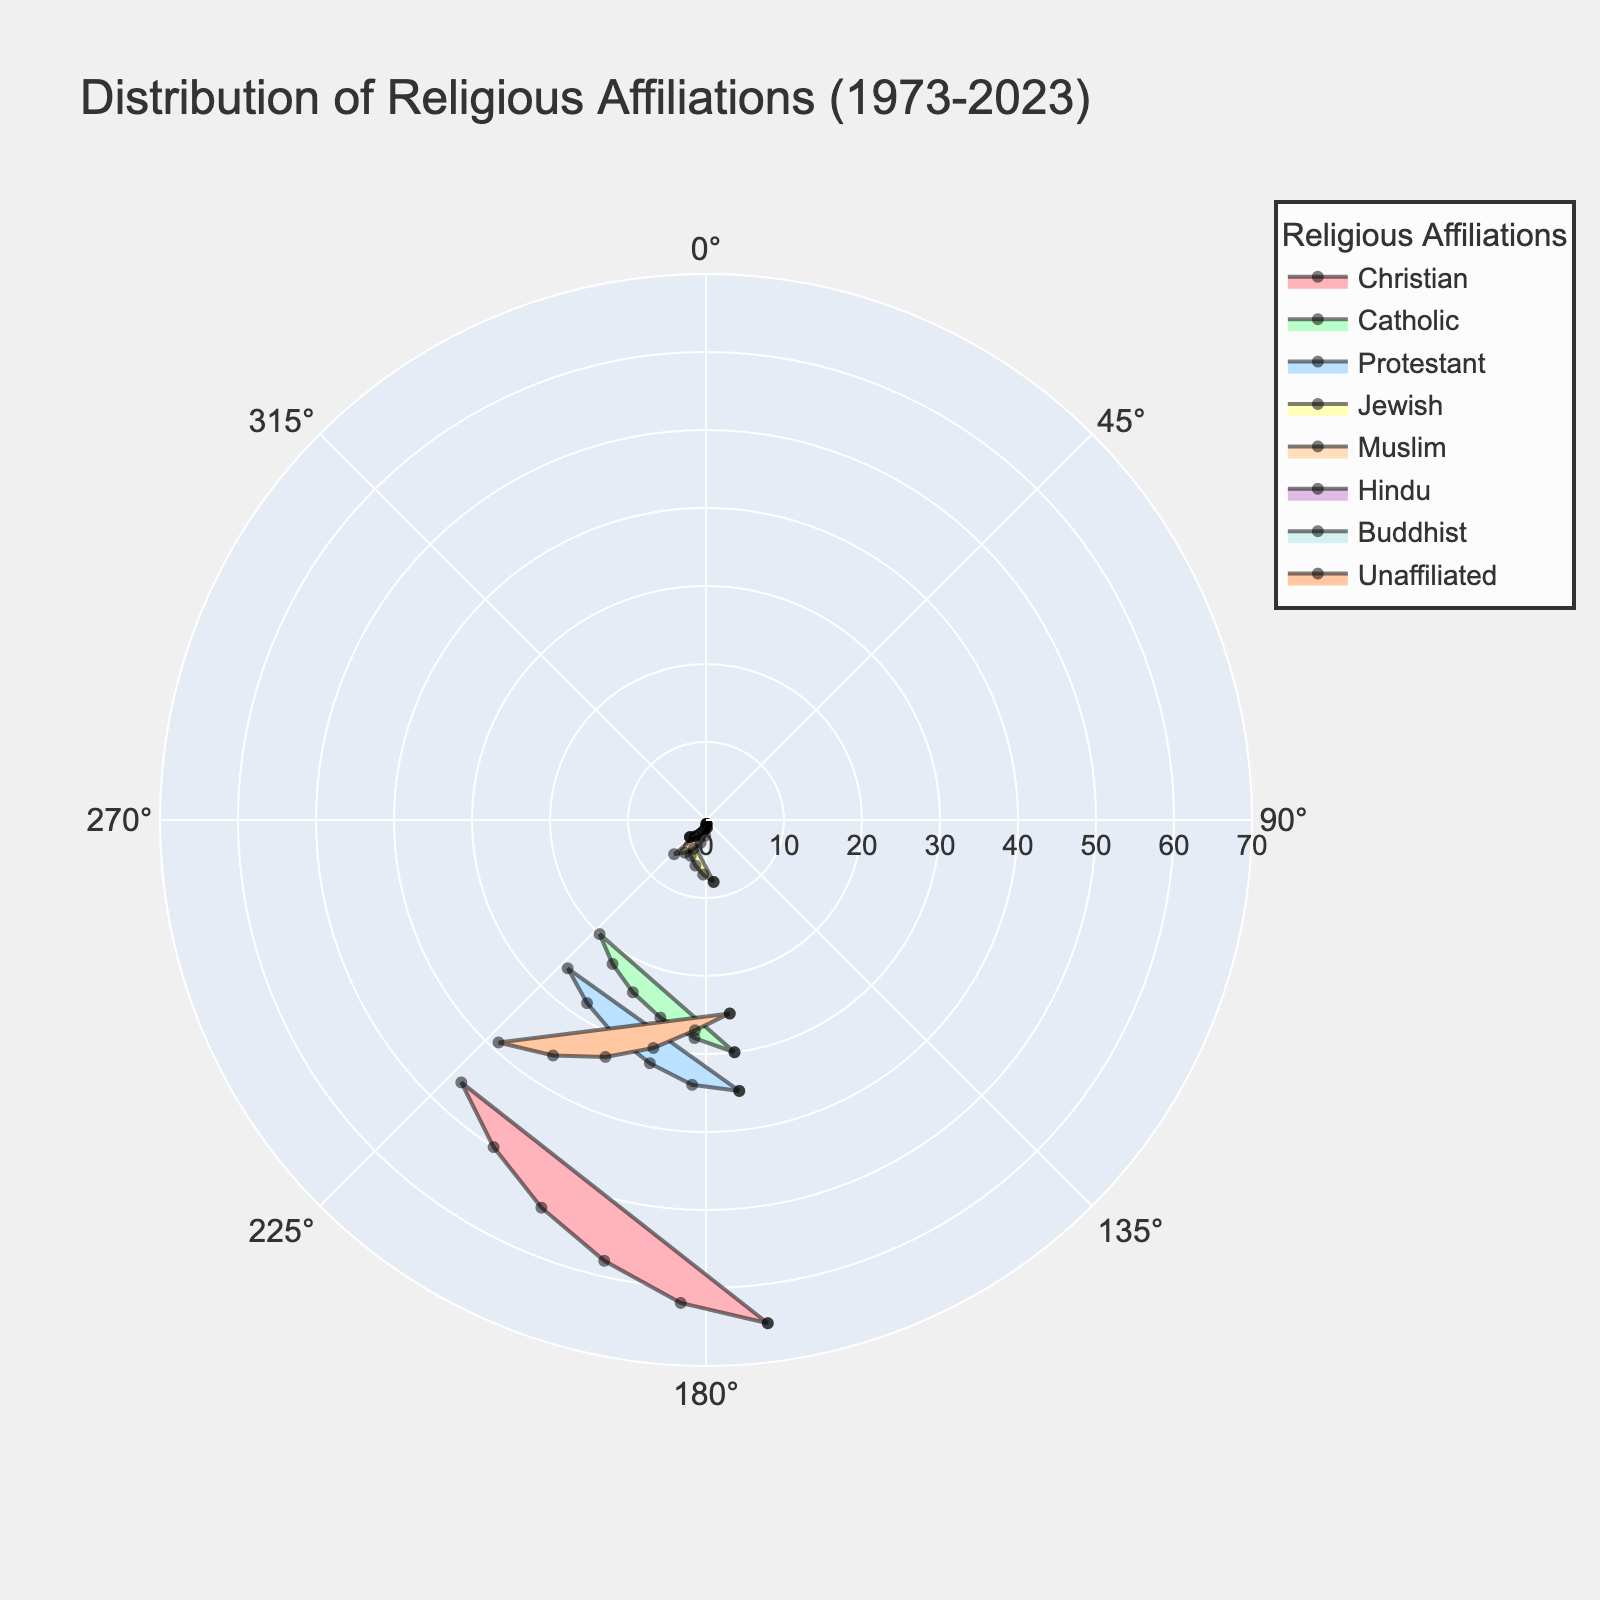What is the title of the figure? The title is usually found at the top of the figure and summarizes the data being represented. It aids in understanding the general theme of the chart.
Answer: Distribution of Religious Affiliations (1973-2023) How many different religious affiliations are represented in the figure? Count the number of unique categories shown in the chart legend. Each color and label in the legend represents a different affiliation.
Answer: 8 What is the trend in the percentage of the unaffiliated population from 1973 to 2023? Observe the color or label representing the 'Unaffiliated' category across the years on the chart. Track its positioning from 1973 to 2023 to identify the trend.
Answer: Increasing Which religious affiliation had the highest percentage in 1973? Identify the section of the figure corresponding to 1973, then look for the affiliation with the largest span in that year.
Answer: Christian By how many percentage points did the Christian population decrease from 1973 to 2023? Subtract the percentage of Christians in 2023 from the percentage in 1973 (65 - 46).
Answer: 19 What is the relationship between the Protestant and Catholic populations over time? Observe the 'Protestant' and 'Catholic' sections from 1973 to 2023. Note changes in their relative proportions, whether they grew, shrank, or remained stable.
Answer: Both decrease, Protestant by 9 points and Catholic by 10 Which affiliation showed the most significant growth between 1973 and 2023? Identify the affiliation with the most noticeable increase by tracking each category from 1973 to 2023. The one with the largest percentage point increase is the answer.
Answer: Unaffiliated What is the collective percentage of all affiliations except 'Unaffiliated' in 2023? Sum up the percentages of all affiliations other than 'Unaffiliated' for the year 2023: Christian (46) + Catholic (20) + Protestant (26) + Jewish (3) + Muslim (6) + Hindu (3) + Buddhist (3).
Answer: 107 In what year did the Muslim population reach 4%? Locate the year where the circle segment for the 'Muslim' category intersects the 4% radial axis.
Answer: 2003 Compare the Hindu and Buddhist populations in 2013. Which one is higher and by how much? Find the values for Hindu and Buddhist for the year 2013 and subtract the smaller from the larger. Hindu (2.5%) and Buddhist (2.5%) have the same value, so no difference.
Answer: They are equal, difference is 0 